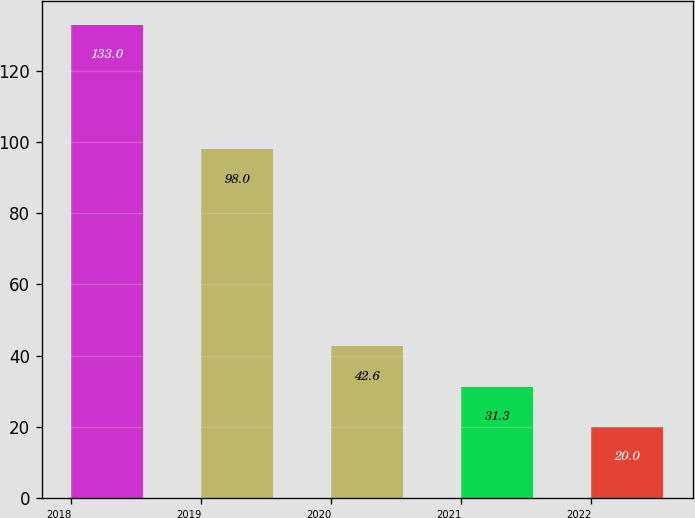<chart> <loc_0><loc_0><loc_500><loc_500><bar_chart><fcel>2018<fcel>2019<fcel>2020<fcel>2021<fcel>2022<nl><fcel>133<fcel>98<fcel>42.6<fcel>31.3<fcel>20<nl></chart> 